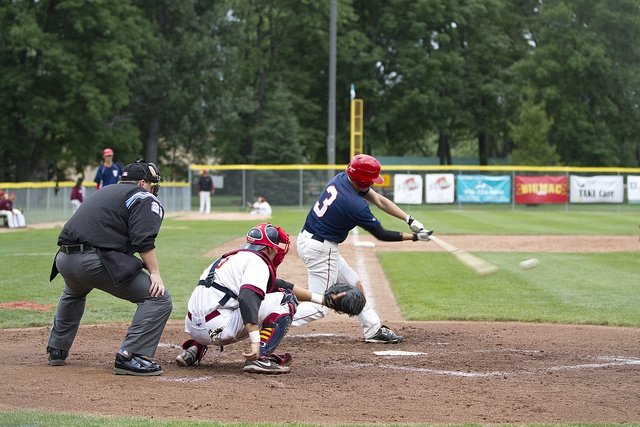Describe the objects in this image and their specific colors. I can see people in black, gray, and darkgray tones, people in black, white, gray, and darkgray tones, people in black, lightgray, navy, and darkgray tones, baseball glove in black, gray, and darkgray tones, and baseball bat in black, beige, and tan tones in this image. 